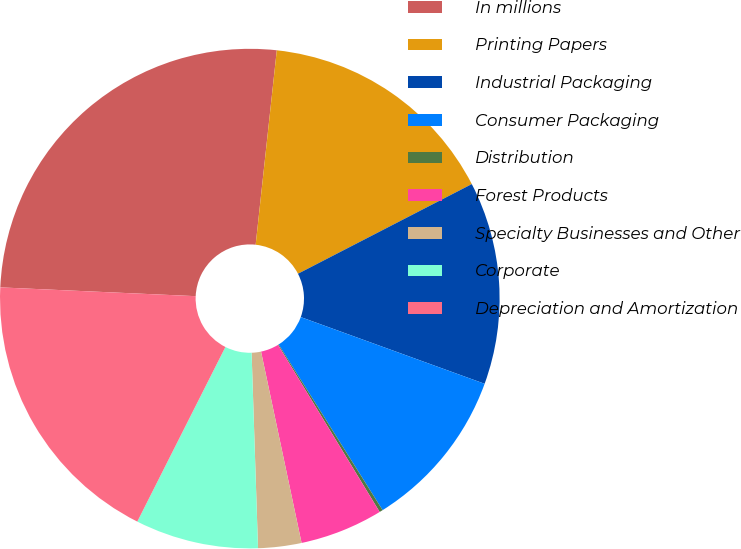Convert chart to OTSL. <chart><loc_0><loc_0><loc_500><loc_500><pie_chart><fcel>In millions<fcel>Printing Papers<fcel>Industrial Packaging<fcel>Consumer Packaging<fcel>Distribution<fcel>Forest Products<fcel>Specialty Businesses and Other<fcel>Corporate<fcel>Depreciation and Amortization<nl><fcel>26.01%<fcel>15.7%<fcel>13.12%<fcel>10.54%<fcel>0.22%<fcel>5.38%<fcel>2.8%<fcel>7.96%<fcel>18.28%<nl></chart> 